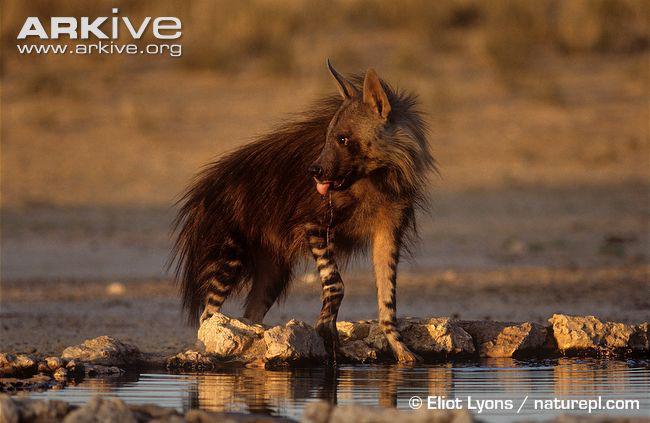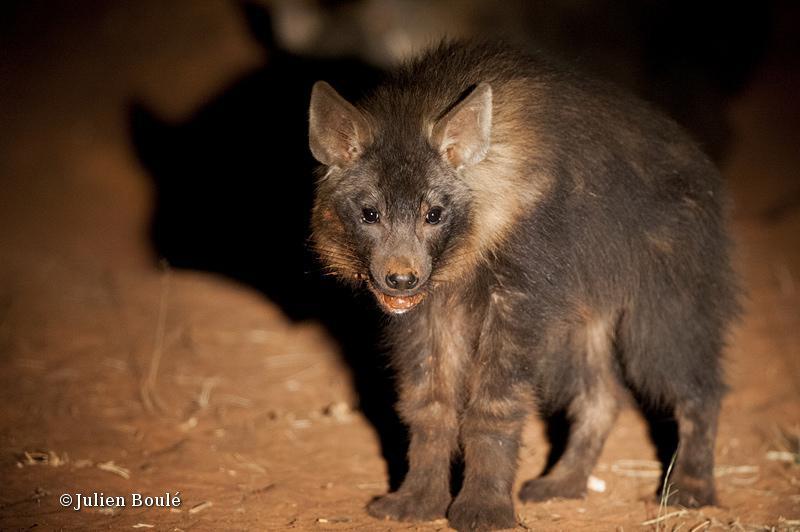The first image is the image on the left, the second image is the image on the right. Examine the images to the left and right. Is the description "There is a hyena standing in water." accurate? Answer yes or no. Yes. 